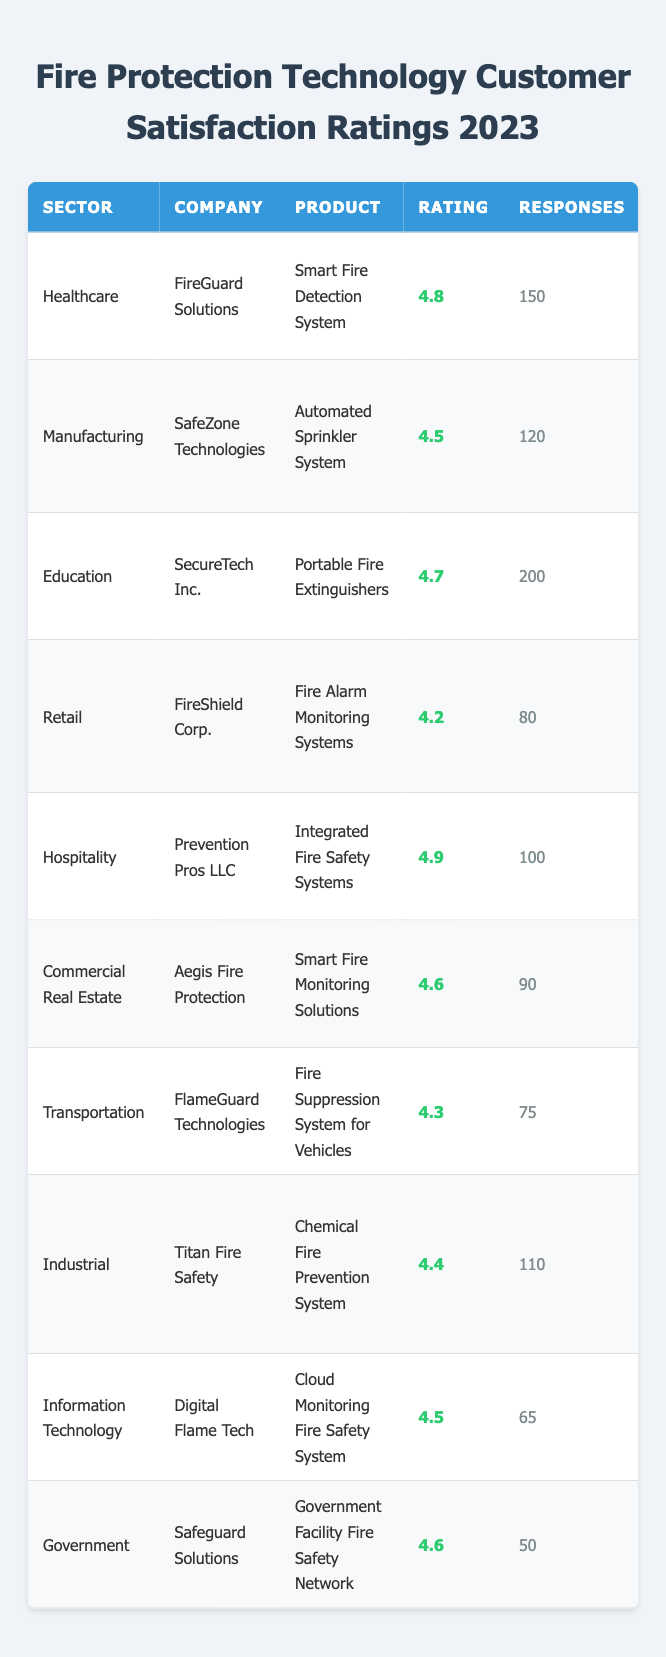What was the highest customer satisfaction rating in the table? The highest rating is found in the Healthcare sector for the product "Smart Fire Detection System" with a rating of 4.8.
Answer: 4.8 Which company received the lowest rating for their product? The lowest rating in the table is for "Fire Alarm Monitoring Systems" from FireShield Corp., which received a rating of 4.2.
Answer: FireShield Corp What is the average customer satisfaction rating across all sectors? To find the average, sum all ratings (4.8 + 4.5 + 4.7 + 4.2 + 4.9 + 4.6 + 4.3 + 4.4 + 4.5 + 4.6 = 46.5) and divide by the number of products (10). So, 46.5 / 10 = 4.65.
Answer: 4.65 How many total customer responses were there across all products? Adding the number of responses: 150 + 120 + 200 + 80 + 100 + 90 + 75 + 110 + 65 + 50 equals 1,120 responses in total.
Answer: 1,120 Is there a product from the Hospitality sector that has a customer satisfaction rating above 4.5? Yes, the product "Integrated Fire Safety Systems" from Prevention Pros LLC has a rating of 4.9, which is above 4.5.
Answer: Yes Which sector had the highest number of customer responses, and what was that number? The Education sector had the highest number of responses with 200 for the product "Portable Fire Extinguishers."
Answer: Education, 200 What is the difference between the highest and lowest customer satisfaction ratings in the table? The highest rating is 4.9 (Hospitality sector) and the lowest is 4.2 (Retail sector). The difference is 4.9 - 4.2 = 0.7.
Answer: 0.7 Which company and product had the most customer responses, and what was that number? SecureTech Inc. with their product "Portable Fire Extinguishers" had the most responses at 200.
Answer: SecureTech Inc., 200 Are there any companies that received customer satisfaction ratings of 4.5 or higher? Yes, multiple companies received ratings of 4.5 or higher, including FireGuard Solutions (4.8) and Prevention Pros LLC (4.9).
Answer: Yes What percentage of the total responses came from the Retail sector? The Retail sector had 80 responses. To find the percentage, divide 80 by the total responses (1,120) and multiply by 100: (80/1120)*100 = 7.14%.
Answer: 7.14% 